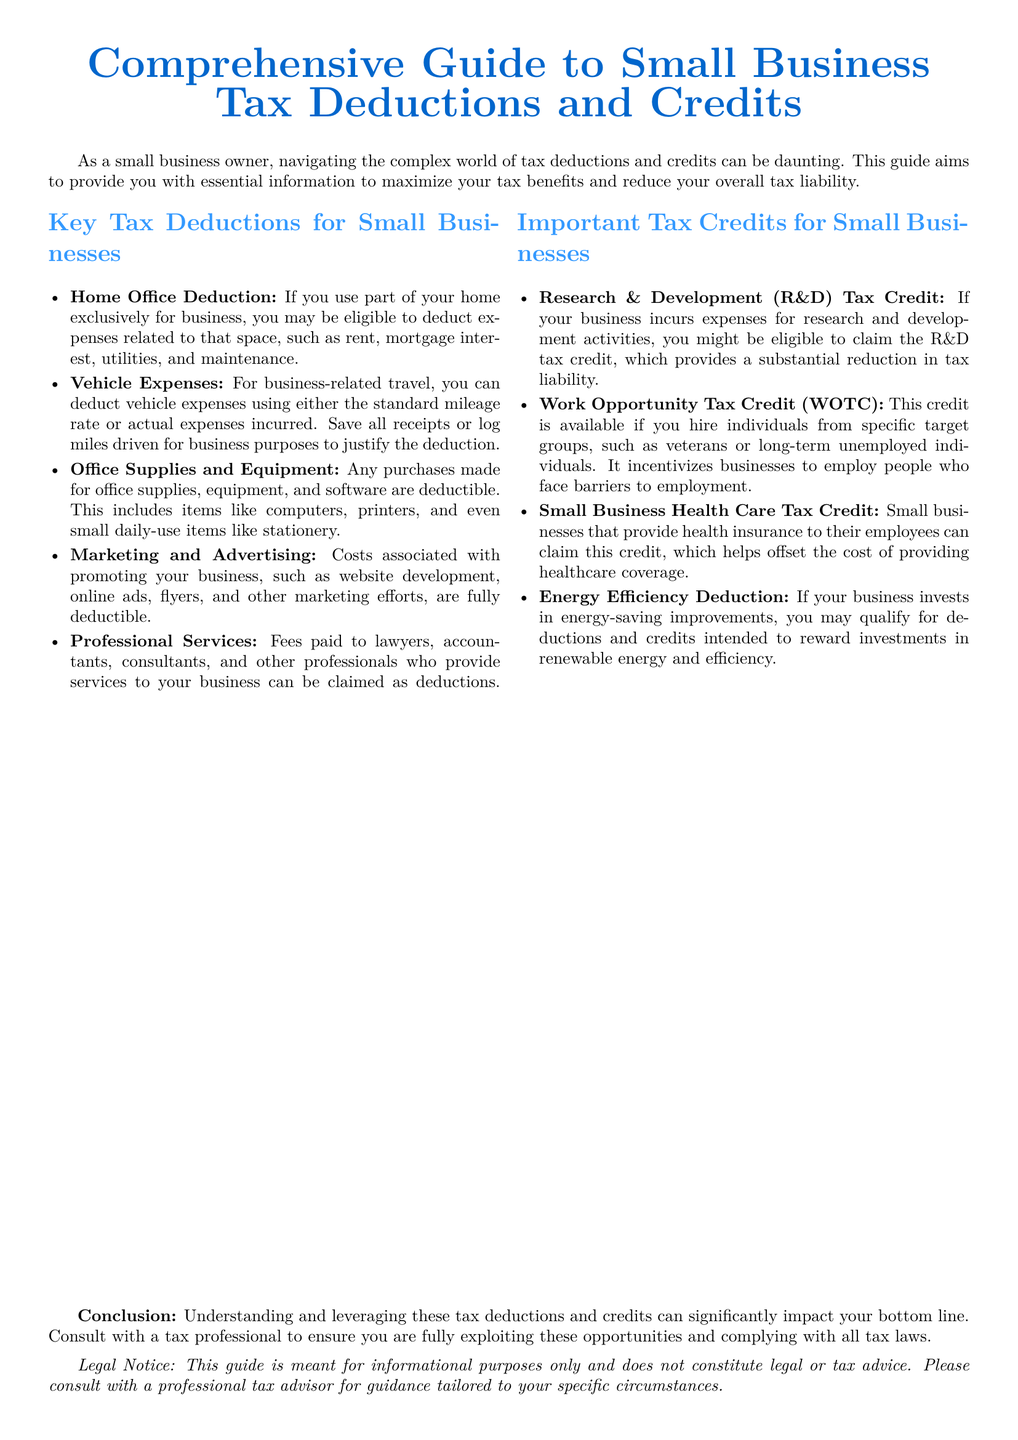What is the title of the document? The title is prominently displayed at the beginning of the document, providing an overview of its content.
Answer: Comprehensive Guide to Small Business Tax Deductions and Credits What is the first key tax deduction listed? The deductions are presented in a bullet point format, where the first deduction is specifically highlighted.
Answer: Home Office Deduction Which tax credit is related to hiring specific target groups? The relevant credit is explicitly mentioned under the important tax credits section of the document.
Answer: Work Opportunity Tax Credit (WOTC) How does the document suggest tracking vehicle expenses? The document advises how to maintain records necessary for claiming deductions related to vehicle usage.
Answer: Save all receipts or log miles driven What deduction is available for energy-saving improvements? The document lists the type of deduction associated with energy efficiency, indicating its importance.
Answer: Energy Efficiency Deduction What type of document is this? The nature of the document is defined in the context of its purpose and content.
Answer: Legal brief Who should you consult for tax-related advice according to the document? The conclusion encourages seeking professional guidance to ensure tax benefits are maximized.
Answer: Tax professional What are the deductions and credits meant to do? The document outlines the primary purpose of deductions and credits for small businesses in the conclusion.
Answer: Maximize tax benefits and reduce tax liability 